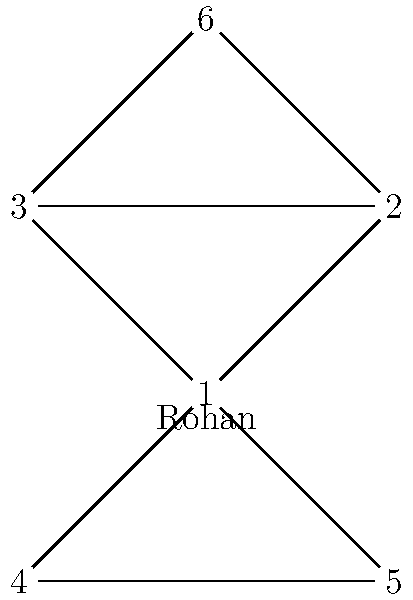In the social network graph of your rowing club, where nodes represent members and edges represent friendships, you notice that Rohan (node 1) is directly connected to four other members. What is the clustering coefficient of Rohan's immediate network? To find the clustering coefficient of Rohan's immediate network, we need to follow these steps:

1. Identify Rohan's neighbors: Nodes 2, 3, 4, and 5 are directly connected to Rohan (node 1).

2. Count the number of edges between Rohan's neighbors:
   - Edge between 2 and 3
   - Edge between 4 and 5
   Total: 2 edges

3. Calculate the maximum possible edges between Rohan's neighbors:
   Maximum edges = $\frac{n(n-1)}{2}$, where $n$ is the number of neighbors
   $n = 4$
   Maximum edges = $\frac{4(4-1)}{2} = \frac{4 \times 3}{2} = 6$

4. Calculate the clustering coefficient:
   Clustering coefficient = $\frac{\text{Actual edges}}{\text{Maximum possible edges}}$
   $= \frac{2}{6} = \frac{1}{3} \approx 0.333$

Therefore, the clustering coefficient of Rohan's immediate network is $\frac{1}{3}$ or approximately 0.333.
Answer: $\frac{1}{3}$ 